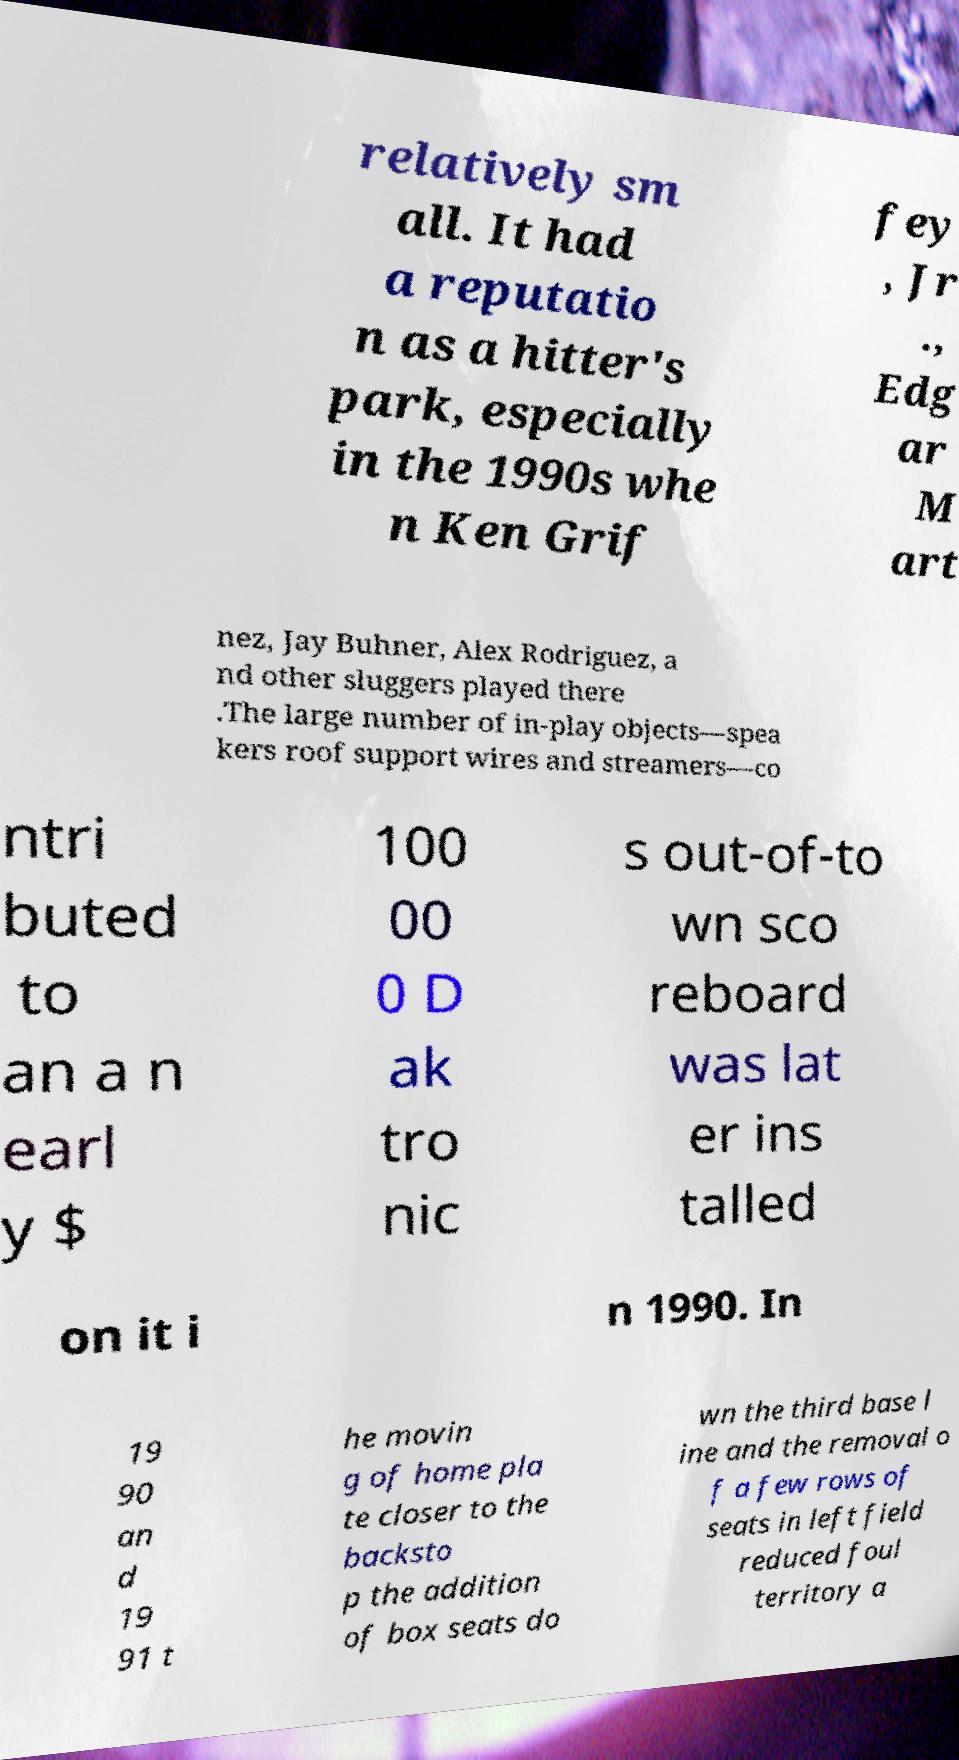Can you read and provide the text displayed in the image?This photo seems to have some interesting text. Can you extract and type it out for me? relatively sm all. It had a reputatio n as a hitter's park, especially in the 1990s whe n Ken Grif fey , Jr ., Edg ar M art nez, Jay Buhner, Alex Rodriguez, a nd other sluggers played there .The large number of in-play objects—spea kers roof support wires and streamers—co ntri buted to an a n earl y $ 100 00 0 D ak tro nic s out-of-to wn sco reboard was lat er ins talled on it i n 1990. In 19 90 an d 19 91 t he movin g of home pla te closer to the backsto p the addition of box seats do wn the third base l ine and the removal o f a few rows of seats in left field reduced foul territory a 